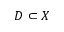<formula> <loc_0><loc_0><loc_500><loc_500>D \subset X</formula> 